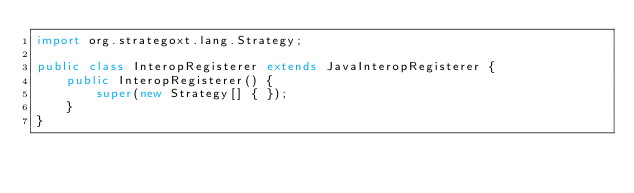<code> <loc_0><loc_0><loc_500><loc_500><_Java_>import org.strategoxt.lang.Strategy;

public class InteropRegisterer extends JavaInteropRegisterer {
    public InteropRegisterer() {
        super(new Strategy[] { });
    }
}
</code> 